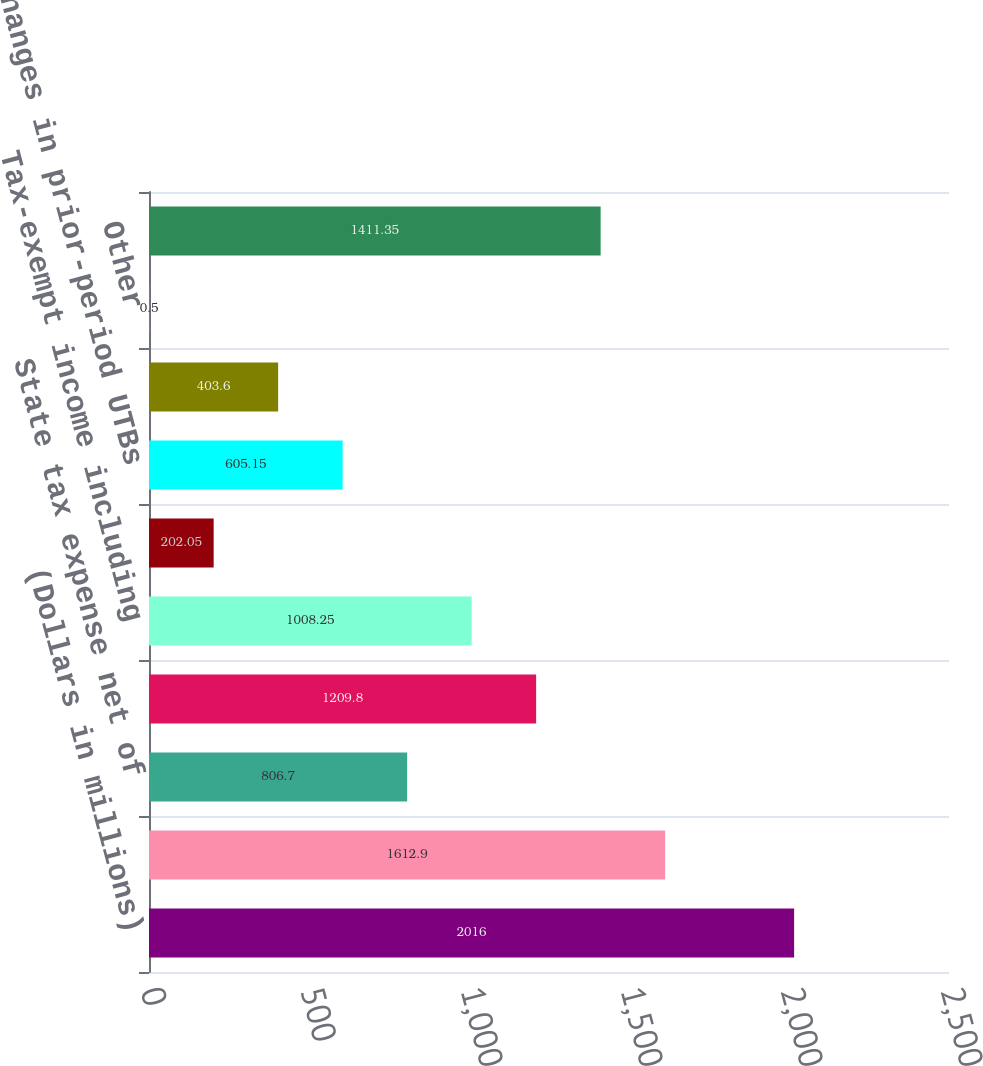<chart> <loc_0><loc_0><loc_500><loc_500><bar_chart><fcel>(Dollars in millions)<fcel>Expected US federal income tax<fcel>State tax expense net of<fcel>Affordable<fcel>Tax-exempt income including<fcel>Nondeductible expenses<fcel>Changes in prior-period UTBs<fcel>Rate differential on non-US<fcel>Other<fcel>Total income tax expense<nl><fcel>2016<fcel>1612.9<fcel>806.7<fcel>1209.8<fcel>1008.25<fcel>202.05<fcel>605.15<fcel>403.6<fcel>0.5<fcel>1411.35<nl></chart> 